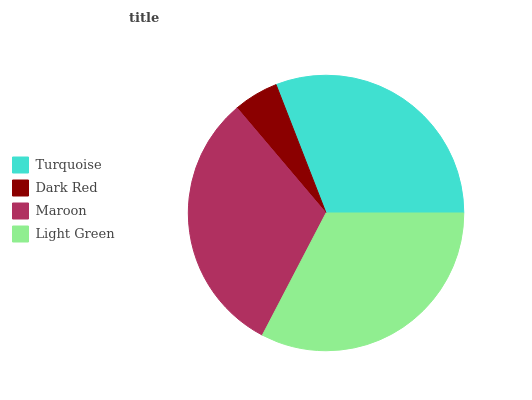Is Dark Red the minimum?
Answer yes or no. Yes. Is Light Green the maximum?
Answer yes or no. Yes. Is Maroon the minimum?
Answer yes or no. No. Is Maroon the maximum?
Answer yes or no. No. Is Maroon greater than Dark Red?
Answer yes or no. Yes. Is Dark Red less than Maroon?
Answer yes or no. Yes. Is Dark Red greater than Maroon?
Answer yes or no. No. Is Maroon less than Dark Red?
Answer yes or no. No. Is Maroon the high median?
Answer yes or no. Yes. Is Turquoise the low median?
Answer yes or no. Yes. Is Dark Red the high median?
Answer yes or no. No. Is Dark Red the low median?
Answer yes or no. No. 